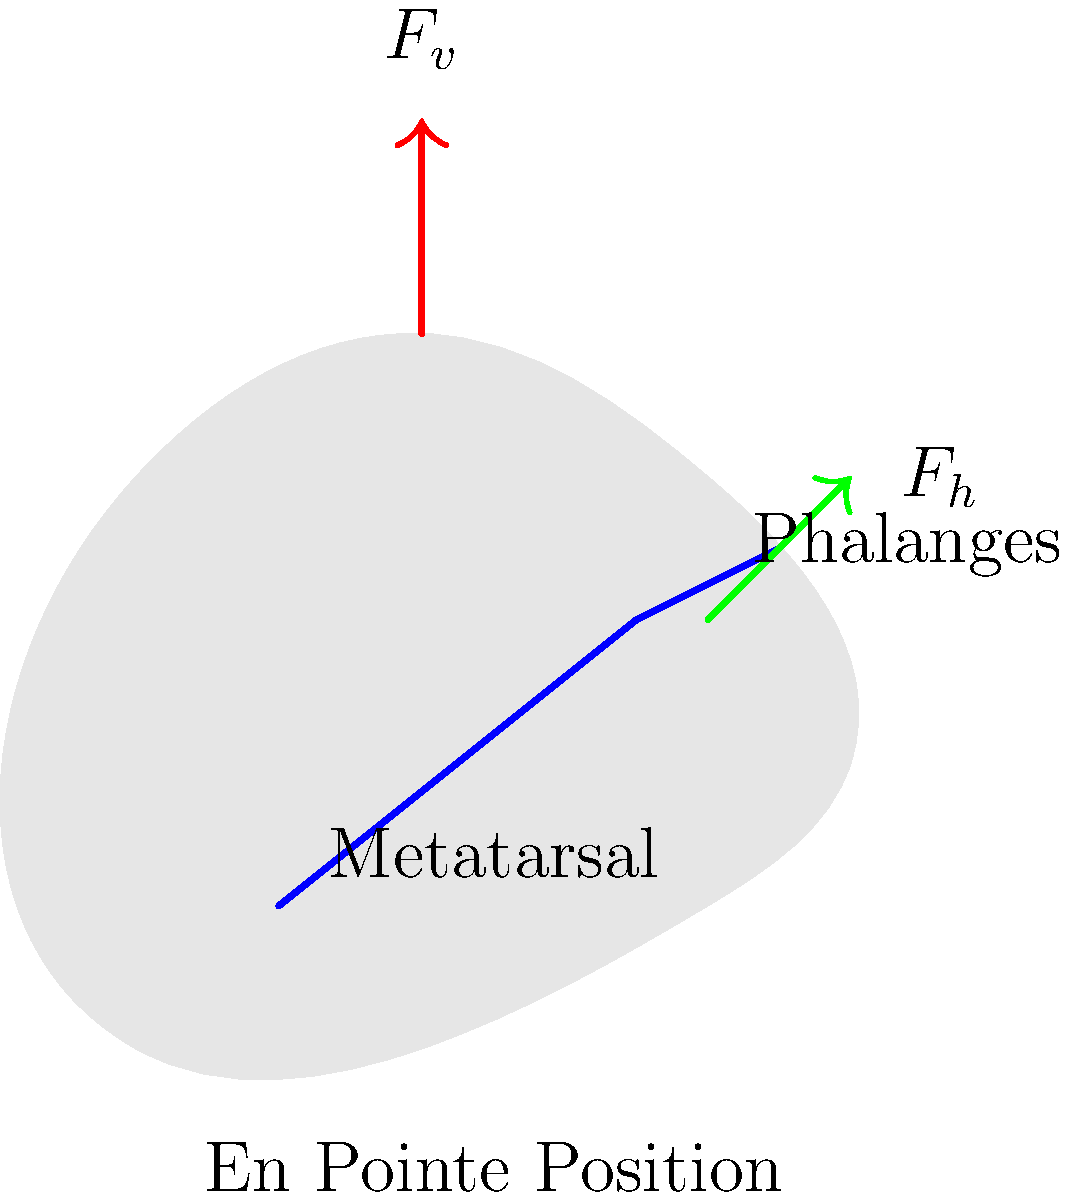Analyze the force distribution on a ballet dancer's foot during the en pointe position. Given that the total weight of the dancer is 500 N and the angle between the vertical axis and the metatarsal bone is 20°, calculate the compressive force along the metatarsal bone. Assume that all the weight is supported on one foot and ignore any muscular forces. To solve this problem, we'll follow these steps:

1) In the en pointe position, the dancer's weight is distributed along the metatarsal bone.

2) We need to decompose the weight force into components parallel and perpendicular to the metatarsal bone.

3) The force along the metatarsal bone (compressive force) is the parallel component.

4) Let's define our variables:
   $W$ = total weight = 500 N
   $\theta$ = angle between vertical and metatarsal = 20°

5) The compressive force ($F_c$) along the metatarsal is given by:

   $F_c = \frac{W}{\cos\theta}$

6) Substituting our values:

   $F_c = \frac{500}{\cos 20°}$

7) Using a calculator or trigonometric tables:

   $\cos 20° \approx 0.9397$

8) Therefore:

   $F_c = \frac{500}{0.9397} \approx 532.1$ N

9) Rounding to the nearest whole number:

   $F_c \approx 532$ N

This result shows that the compressive force along the metatarsal is actually greater than the dancer's weight due to the angled position of the foot.
Answer: 532 N 